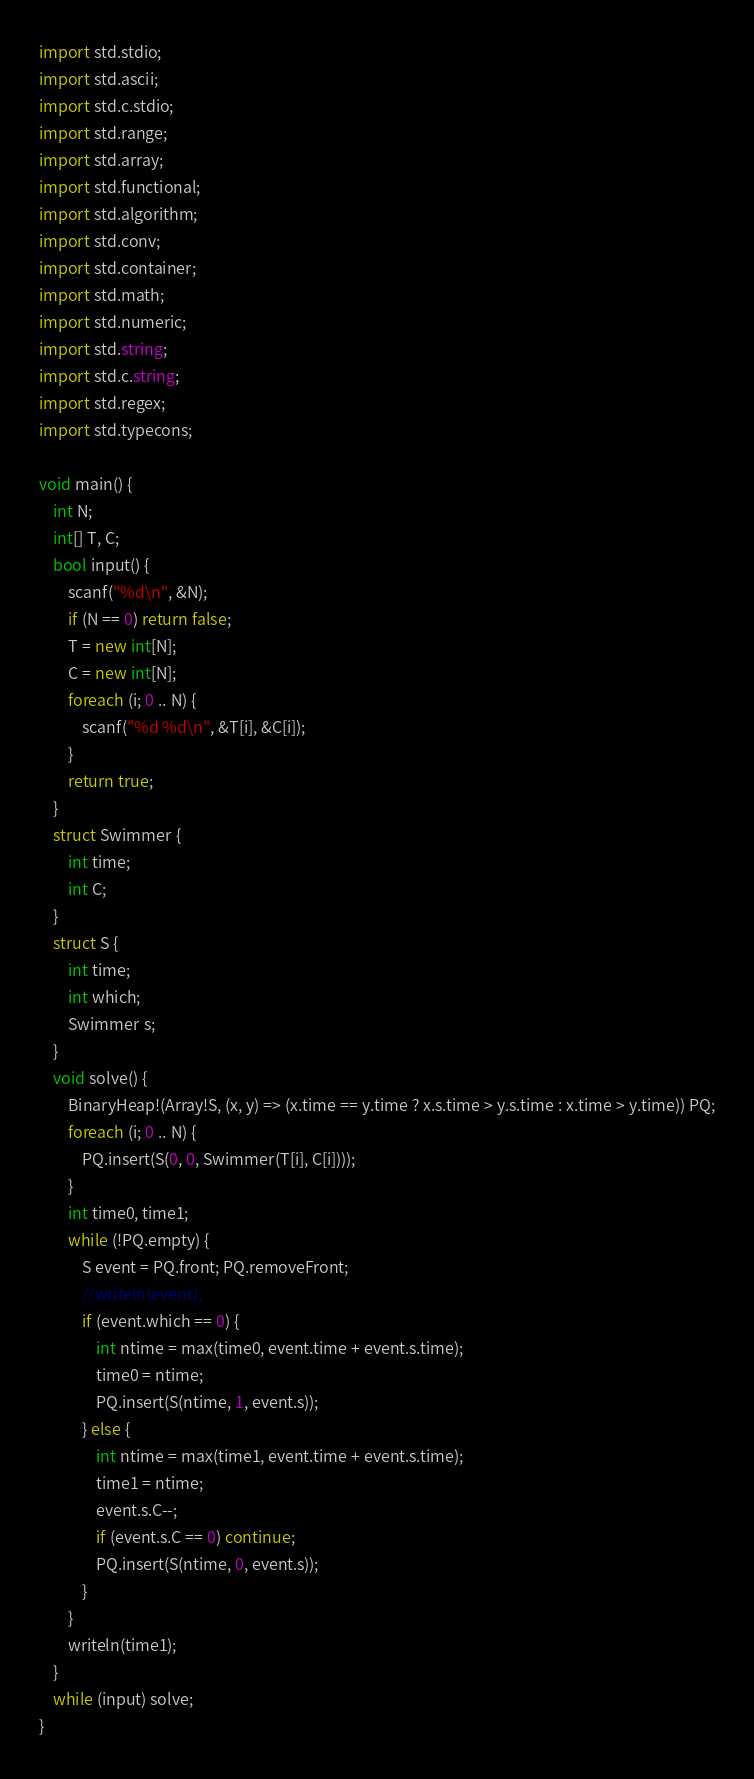Convert code to text. <code><loc_0><loc_0><loc_500><loc_500><_D_>import std.stdio;
import std.ascii;
import std.c.stdio;
import std.range;
import std.array;
import std.functional;
import std.algorithm;
import std.conv;
import std.container;
import std.math;
import std.numeric;
import std.string;
import std.c.string;
import std.regex;
import std.typecons;

void main() {
    int N;
    int[] T, C;
    bool input() {
        scanf("%d\n", &N);
        if (N == 0) return false;
        T = new int[N];
        C = new int[N];
        foreach (i; 0 .. N) {
            scanf("%d %d\n", &T[i], &C[i]);
        }
        return true;
    }
    struct Swimmer {
        int time;
        int C;
    }
    struct S {
        int time;
        int which;
        Swimmer s;
    }
    void solve() {
        BinaryHeap!(Array!S, (x, y) => (x.time == y.time ? x.s.time > y.s.time : x.time > y.time)) PQ;
        foreach (i; 0 .. N) {
            PQ.insert(S(0, 0, Swimmer(T[i], C[i])));
        }
        int time0, time1;
        while (!PQ.empty) {
            S event = PQ.front; PQ.removeFront;
            //writeln(event);
            if (event.which == 0) {
                int ntime = max(time0, event.time + event.s.time);
                time0 = ntime;
                PQ.insert(S(ntime, 1, event.s));
            } else {
                int ntime = max(time1, event.time + event.s.time);
                time1 = ntime;
                event.s.C--;
                if (event.s.C == 0) continue;
                PQ.insert(S(ntime, 0, event.s));
            }
        }
        writeln(time1);
    }
    while (input) solve;
}</code> 